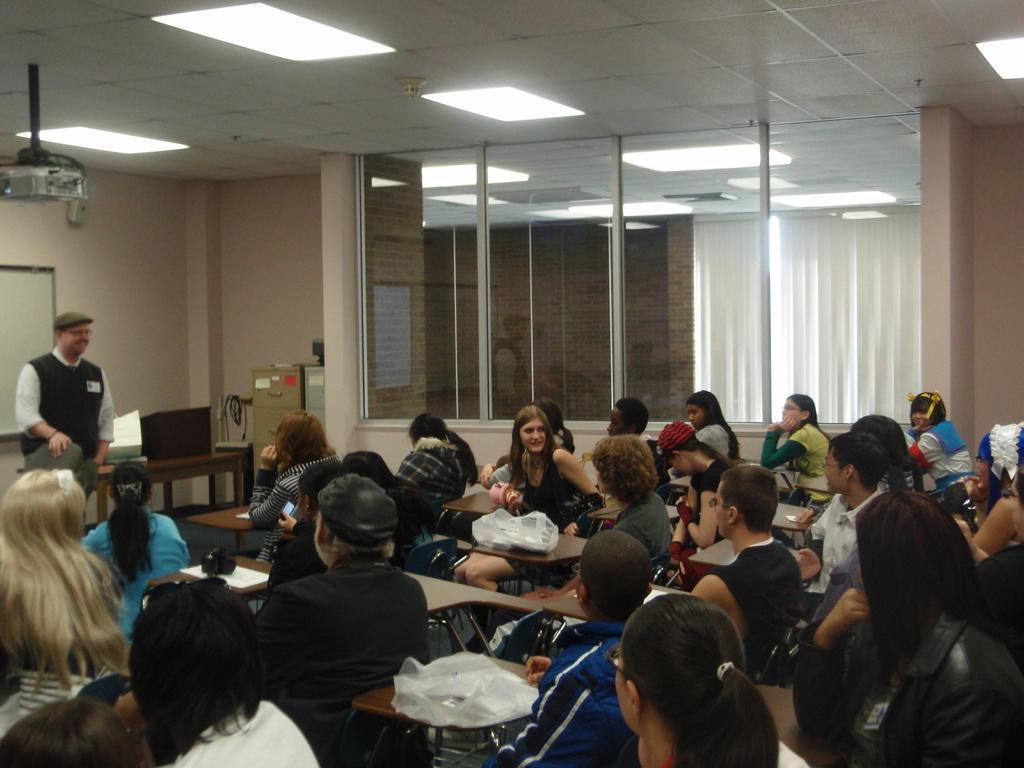In one or two sentences, can you explain what this image depicts? In this image there are a group of people who are sitting on chairs, and there are some tables. On the tables there are some papers and some plastic covers, and on the left side there is one person who is standing beside him there is a table cupboard and some objects. In the background there is a wall, on the wall there is one board and there are some glass windows and curtains, at the top there is ceiling and some lights and on the left side there is projector. 